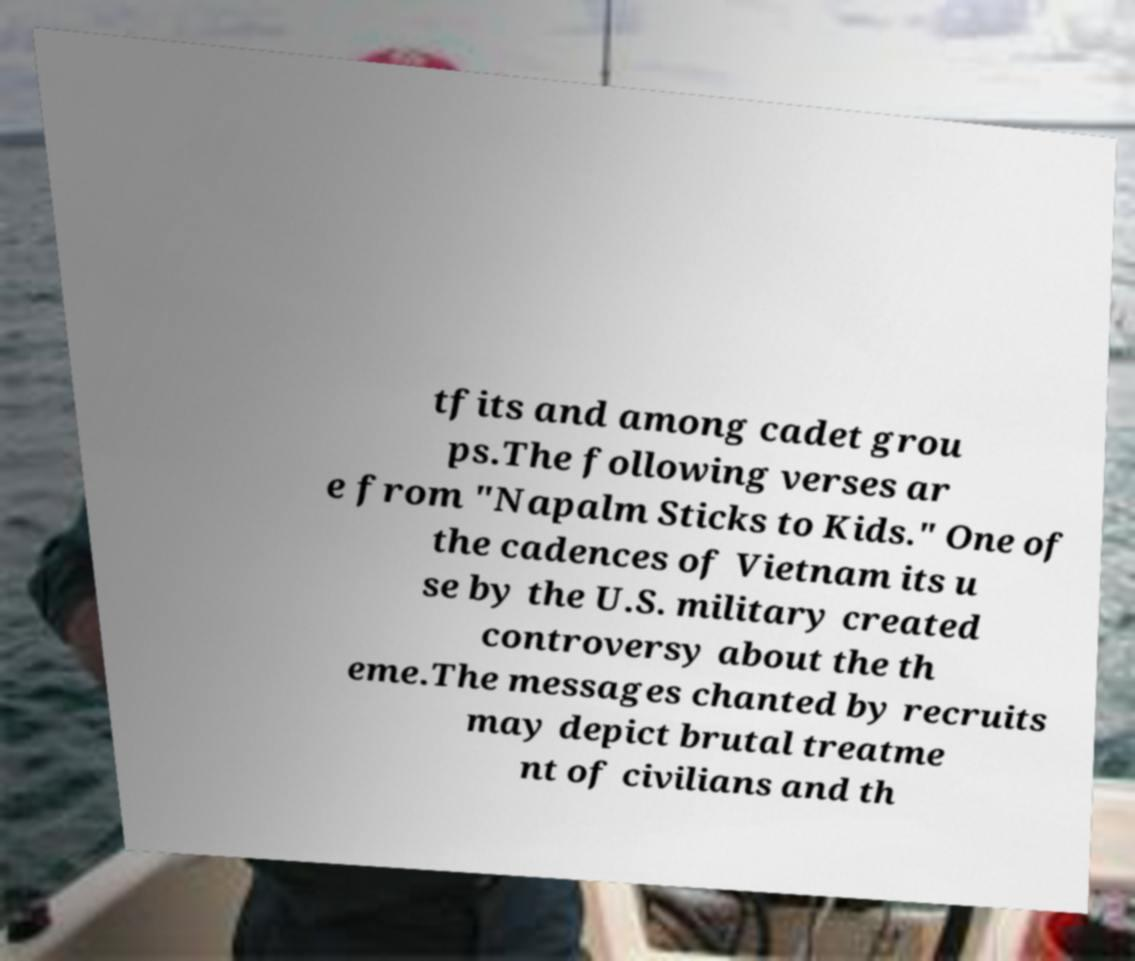Can you accurately transcribe the text from the provided image for me? tfits and among cadet grou ps.The following verses ar e from "Napalm Sticks to Kids." One of the cadences of Vietnam its u se by the U.S. military created controversy about the th eme.The messages chanted by recruits may depict brutal treatme nt of civilians and th 